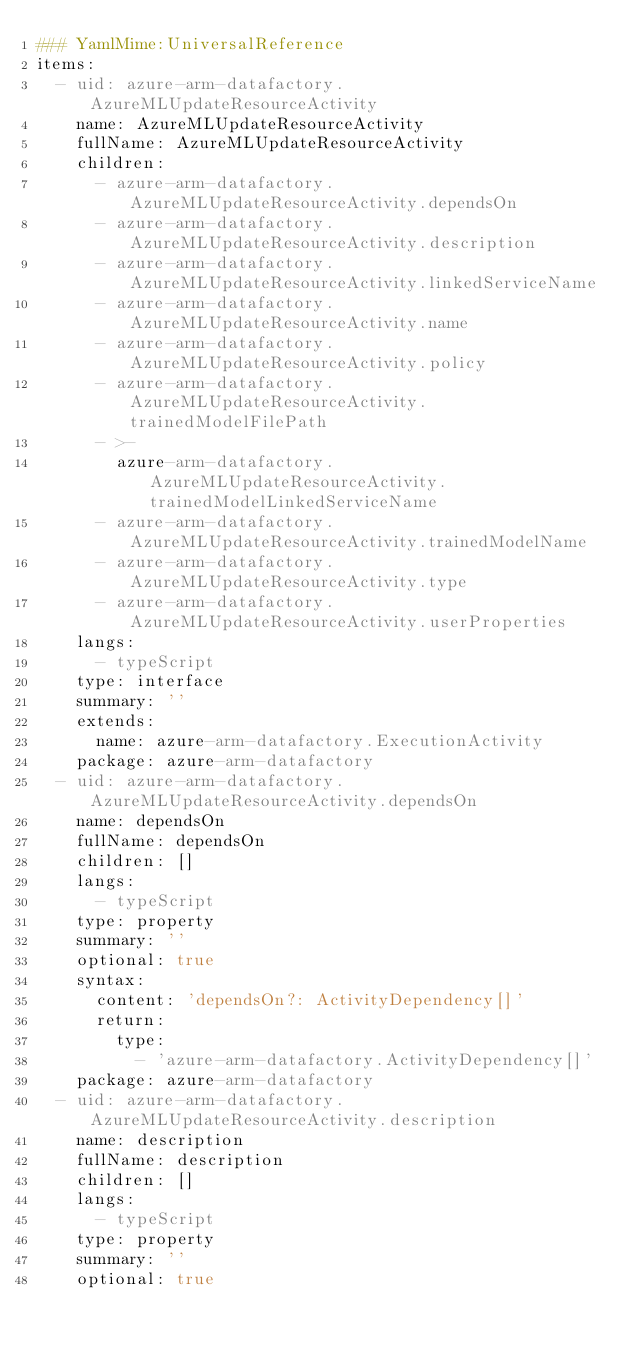Convert code to text. <code><loc_0><loc_0><loc_500><loc_500><_YAML_>### YamlMime:UniversalReference
items:
  - uid: azure-arm-datafactory.AzureMLUpdateResourceActivity
    name: AzureMLUpdateResourceActivity
    fullName: AzureMLUpdateResourceActivity
    children:
      - azure-arm-datafactory.AzureMLUpdateResourceActivity.dependsOn
      - azure-arm-datafactory.AzureMLUpdateResourceActivity.description
      - azure-arm-datafactory.AzureMLUpdateResourceActivity.linkedServiceName
      - azure-arm-datafactory.AzureMLUpdateResourceActivity.name
      - azure-arm-datafactory.AzureMLUpdateResourceActivity.policy
      - azure-arm-datafactory.AzureMLUpdateResourceActivity.trainedModelFilePath
      - >-
        azure-arm-datafactory.AzureMLUpdateResourceActivity.trainedModelLinkedServiceName
      - azure-arm-datafactory.AzureMLUpdateResourceActivity.trainedModelName
      - azure-arm-datafactory.AzureMLUpdateResourceActivity.type
      - azure-arm-datafactory.AzureMLUpdateResourceActivity.userProperties
    langs:
      - typeScript
    type: interface
    summary: ''
    extends:
      name: azure-arm-datafactory.ExecutionActivity
    package: azure-arm-datafactory
  - uid: azure-arm-datafactory.AzureMLUpdateResourceActivity.dependsOn
    name: dependsOn
    fullName: dependsOn
    children: []
    langs:
      - typeScript
    type: property
    summary: ''
    optional: true
    syntax:
      content: 'dependsOn?: ActivityDependency[]'
      return:
        type:
          - 'azure-arm-datafactory.ActivityDependency[]'
    package: azure-arm-datafactory
  - uid: azure-arm-datafactory.AzureMLUpdateResourceActivity.description
    name: description
    fullName: description
    children: []
    langs:
      - typeScript
    type: property
    summary: ''
    optional: true</code> 